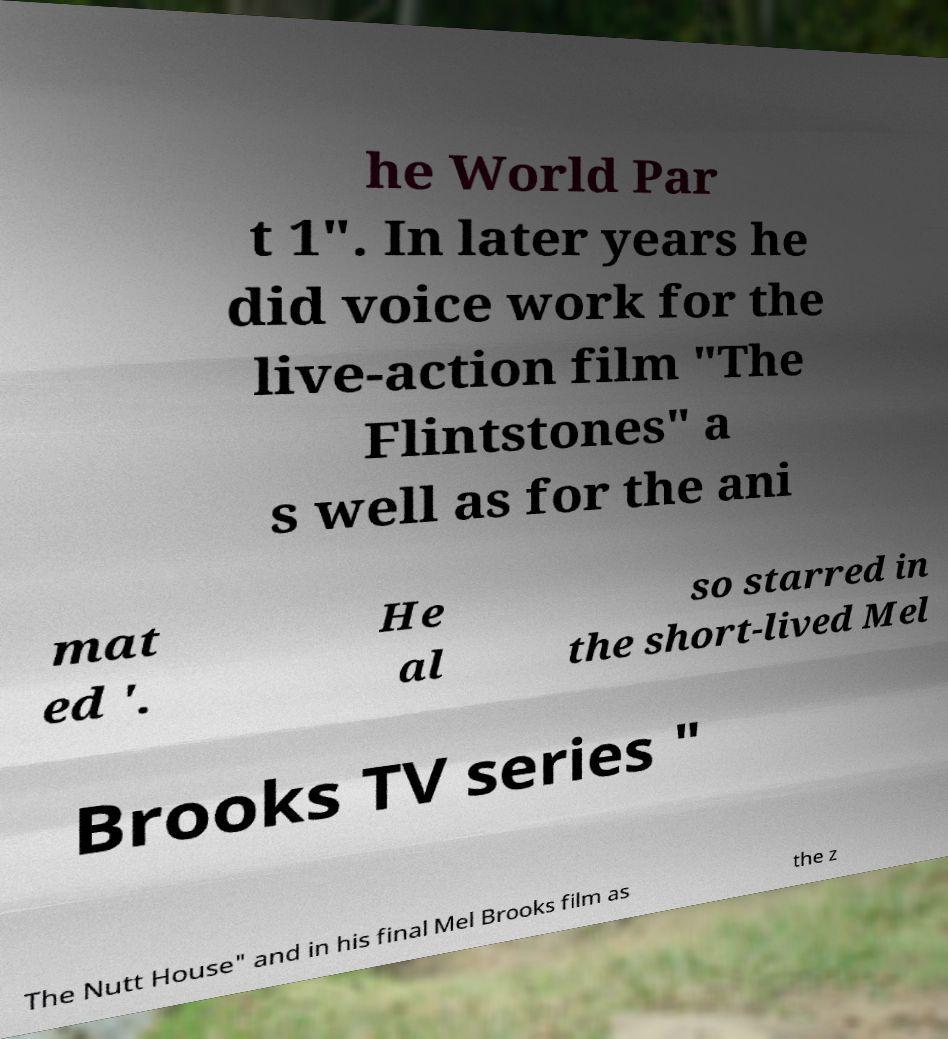I need the written content from this picture converted into text. Can you do that? he World Par t 1". In later years he did voice work for the live-action film "The Flintstones" a s well as for the ani mat ed '. He al so starred in the short-lived Mel Brooks TV series " The Nutt House" and in his final Mel Brooks film as the z 